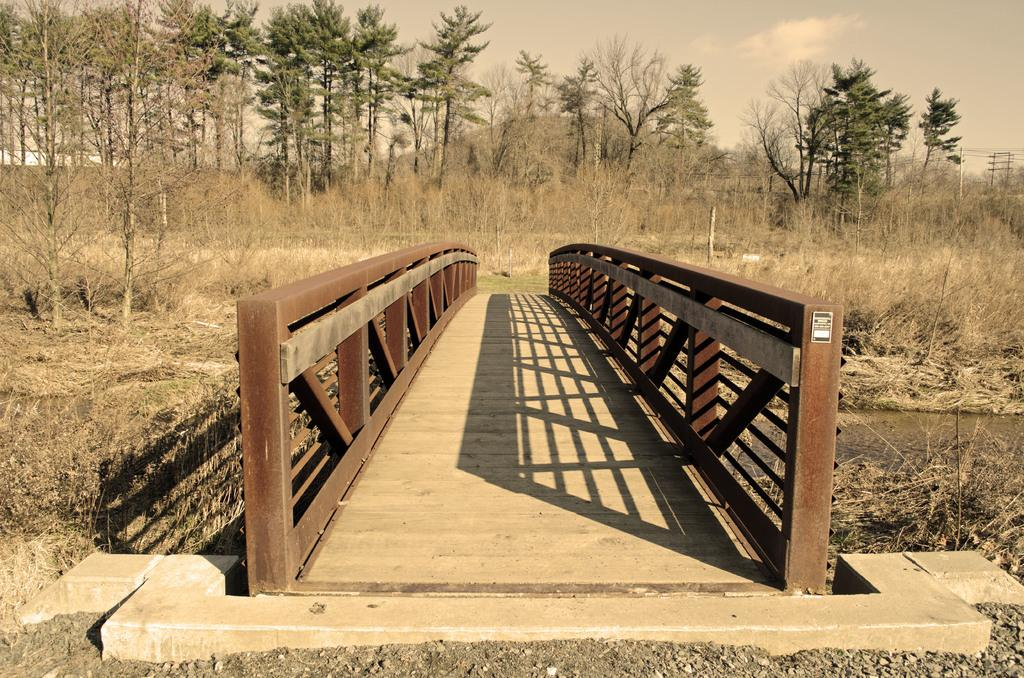What type of terrain can be seen in the image? Ground, trees, plants, and grass are visible in the image. What type of structure is present in the image? There is a wooden bridge in the image. What other objects can be seen in the image? Poles and wires are visible in the image. What natural elements are present in the image? Water and clouds are visible in the image. What is the color of the sky in the image? The sky is visible in the image, and clouds are present. What type of butter is being used to grease the tank in the image? There is no tank or butter present in the image. What is the fifth element in the image? The facts provided do not indicate a specific order or numbering of elements in the image, so it is not possible to determine a "fifth" element. 